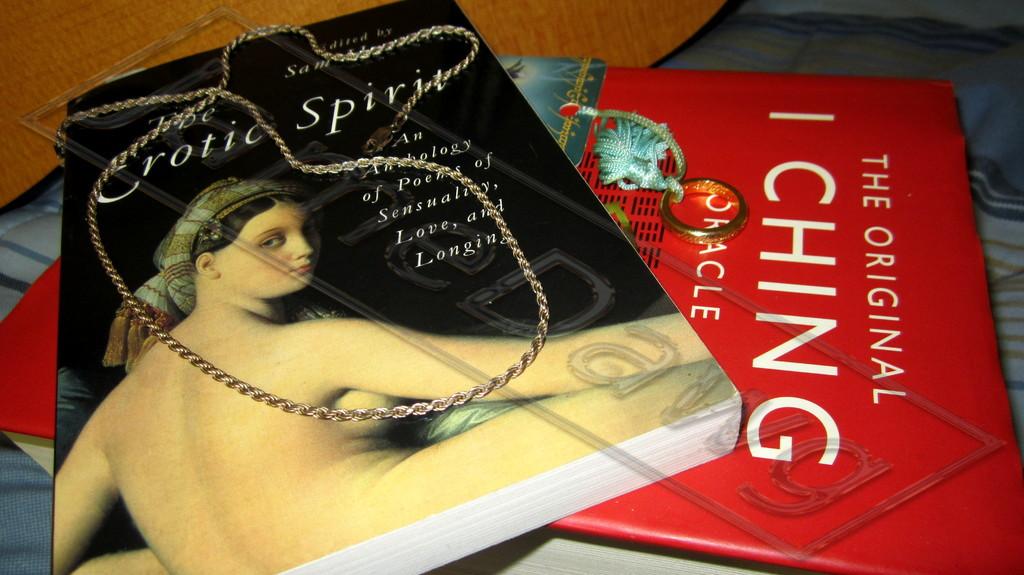What is the title of the work of the black book?
Provide a short and direct response. Erotic spirit. 